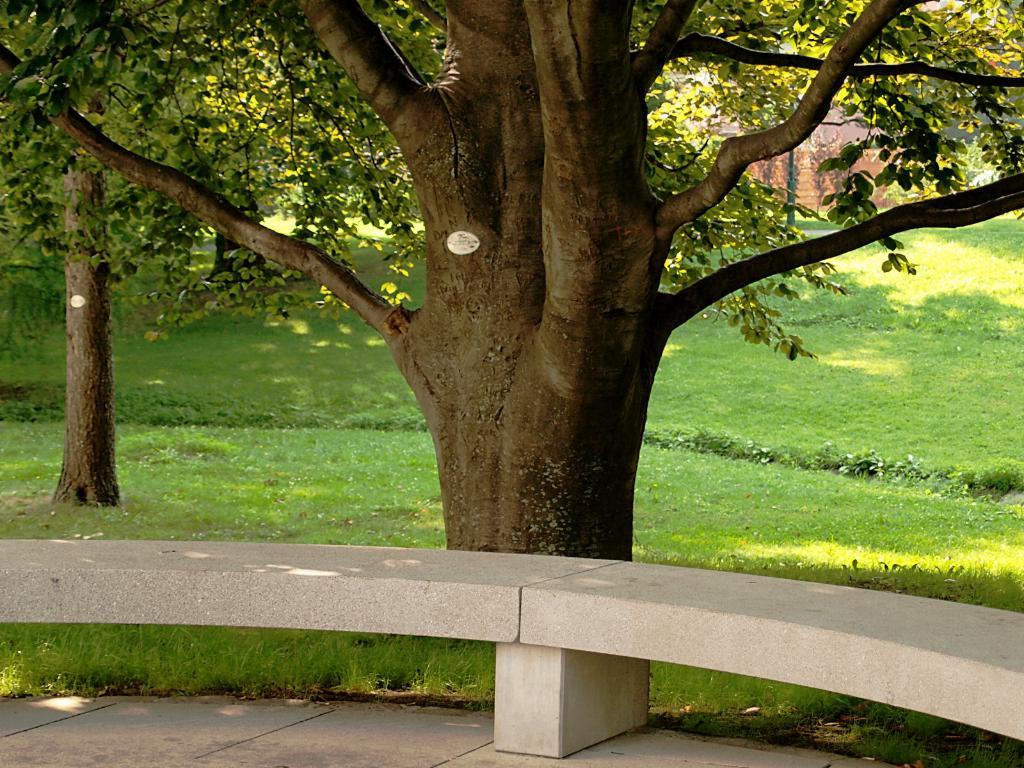What type of vegetation can be seen in the image? There are trees in the image. Where are the trees located? The trees are on a grassland. What type of seating is present in the image? There is a bench in front of the trees. Can you see the eyes of the tiger hiding behind the trees in the image? There is no tiger present in the image, so its eyes cannot be seen. 